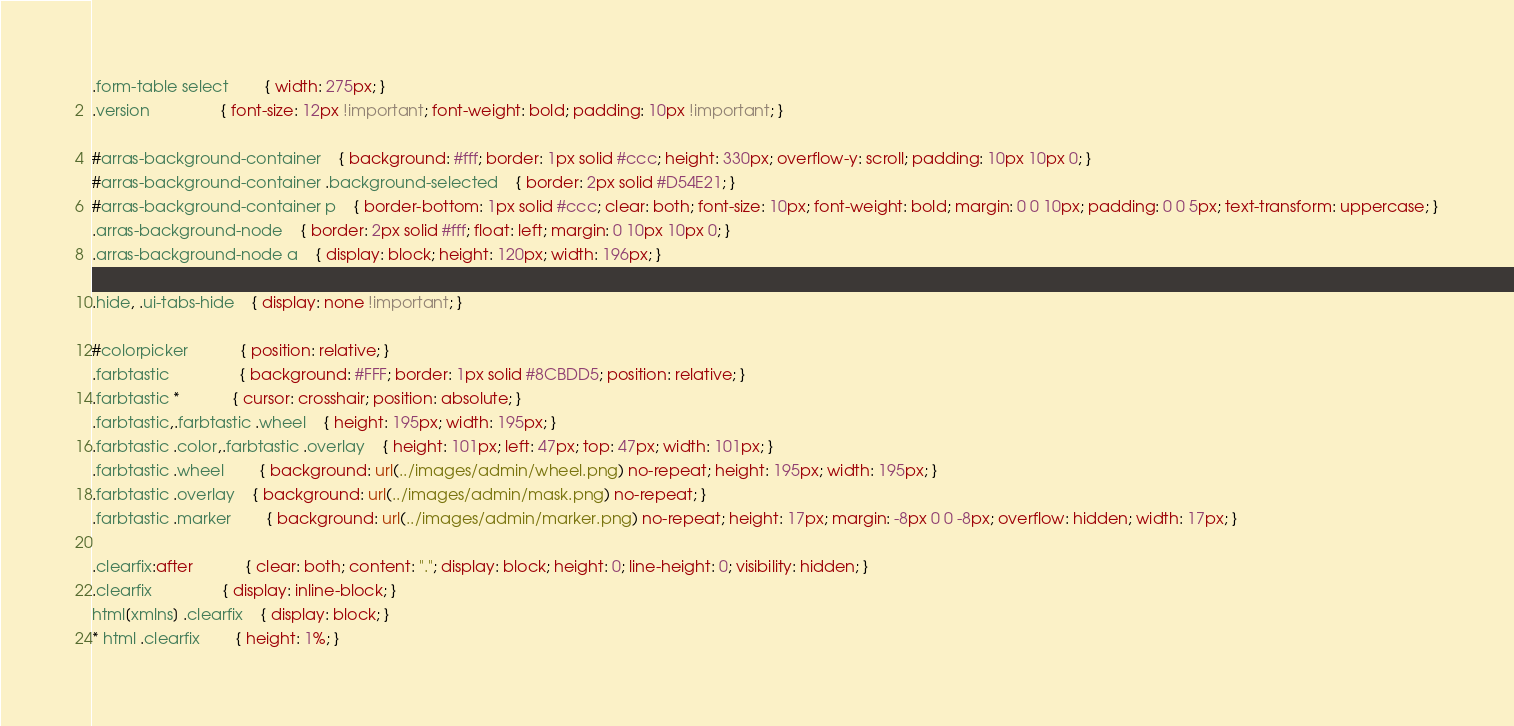Convert code to text. <code><loc_0><loc_0><loc_500><loc_500><_CSS_>.form-table select		{ width: 275px; }
.version				{ font-size: 12px !important; font-weight: bold; padding: 10px !important; }

#arras-background-container	{ background: #fff; border: 1px solid #ccc; height: 330px; overflow-y: scroll; padding: 10px 10px 0; }
#arras-background-container .background-selected	{ border: 2px solid #D54E21; }
#arras-background-container p	{ border-bottom: 1px solid #ccc; clear: both; font-size: 10px; font-weight: bold; margin: 0 0 10px; padding: 0 0 5px; text-transform: uppercase; }
.arras-background-node	{ border: 2px solid #fff; float: left; margin: 0 10px 10px 0; }
.arras-background-node a	{ display: block; height: 120px; width: 196px; }

.hide, .ui-tabs-hide	{ display: none !important; }

#colorpicker			{ position: relative; }
.farbtastic				{ background: #FFF; border: 1px solid #8CBDD5; position: relative; }
.farbtastic *			{ cursor: crosshair; position: absolute; }
.farbtastic,.farbtastic .wheel	{ height: 195px; width: 195px; }
.farbtastic .color,.farbtastic .overlay	{ height: 101px; left: 47px; top: 47px; width: 101px; }
.farbtastic .wheel		{ background: url(../images/admin/wheel.png) no-repeat; height: 195px; width: 195px; }
.farbtastic .overlay	{ background: url(../images/admin/mask.png) no-repeat; }
.farbtastic .marker		{ background: url(../images/admin/marker.png) no-repeat; height: 17px; margin: -8px 0 0 -8px; overflow: hidden; width: 17px; }

.clearfix:after			{ clear: both; content: "."; display: block; height: 0; line-height: 0; visibility: hidden; }
.clearfix				{ display: inline-block; }
html[xmlns] .clearfix	{ display: block; }
* html .clearfix		{ height: 1%; }</code> 